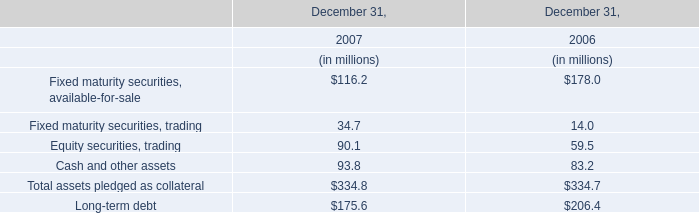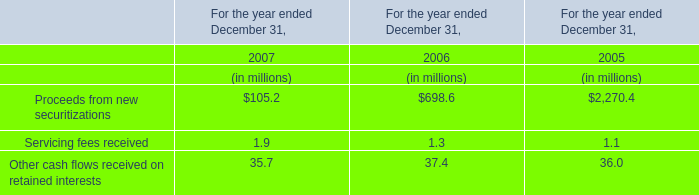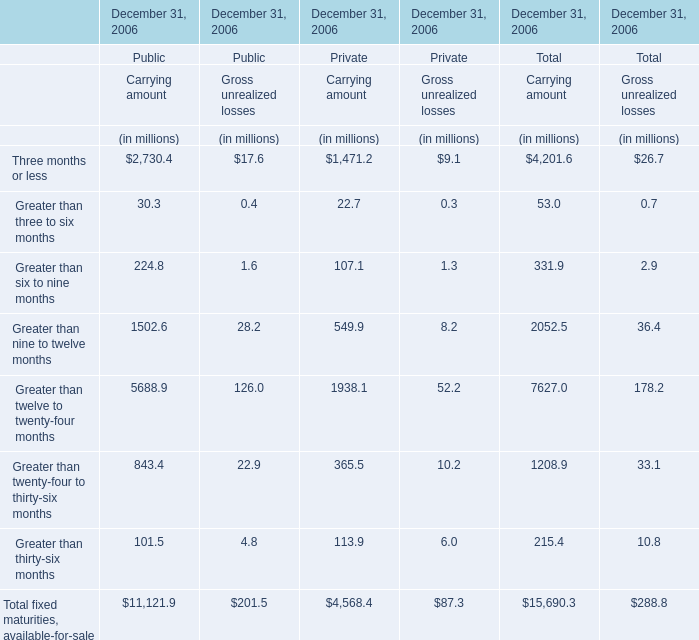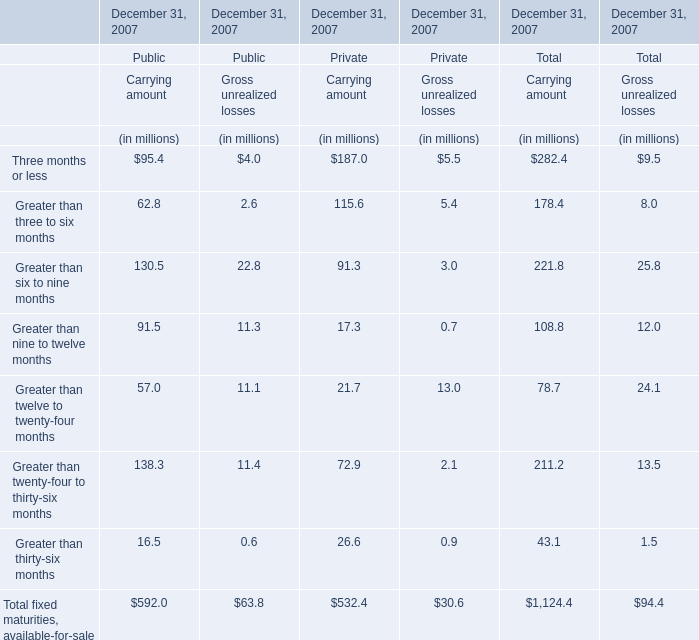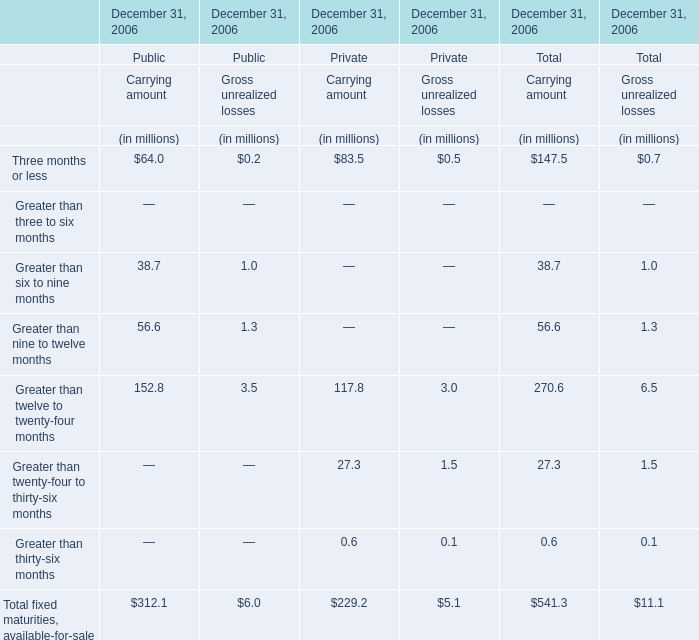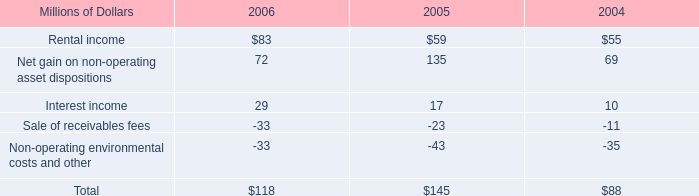what was the percentage change in the rental income from 2005 to 2006 
Computations: ((83 - 59) / 59)
Answer: 0.40678. 